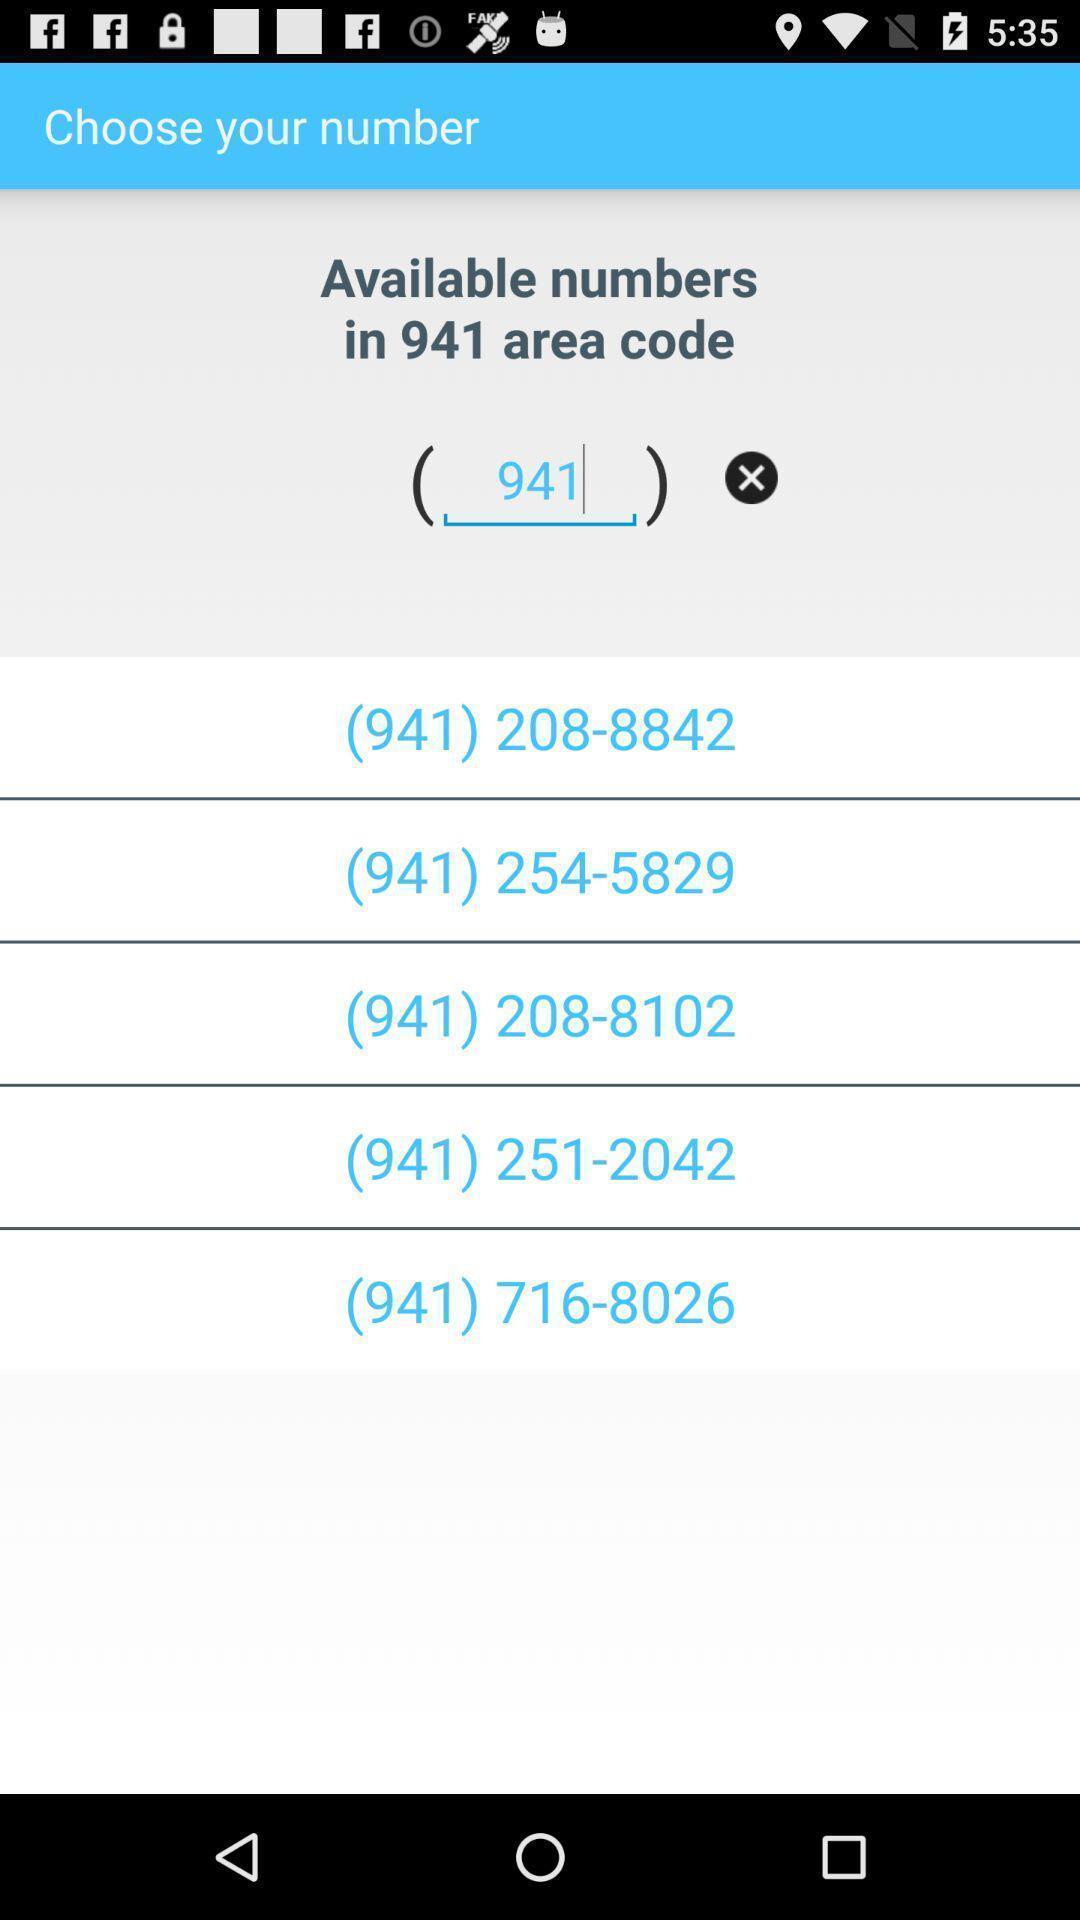Tell me about the visual elements in this screen capture. Page displaying the multiple numbers. 